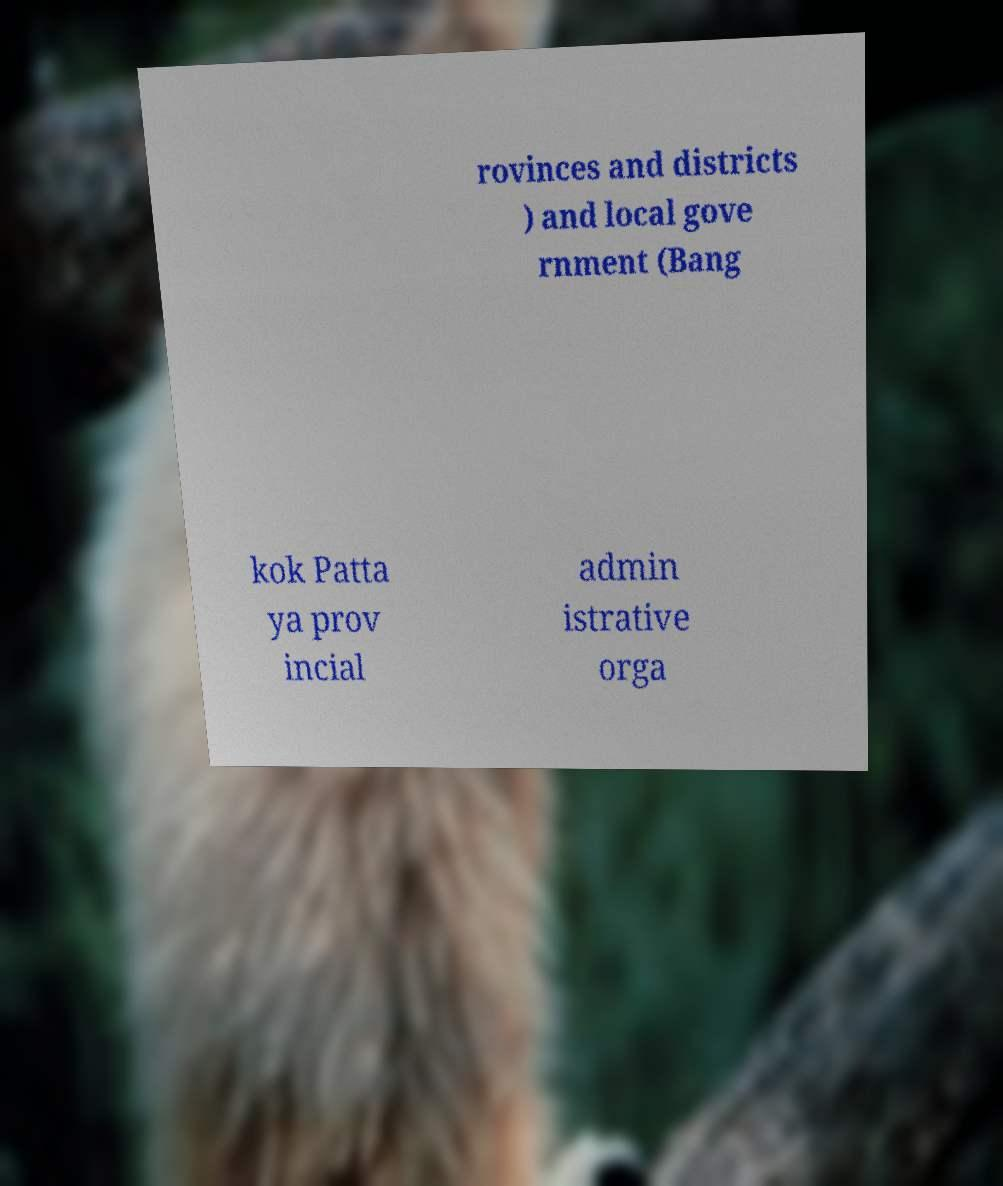Please identify and transcribe the text found in this image. rovinces and districts ) and local gove rnment (Bang kok Patta ya prov incial admin istrative orga 